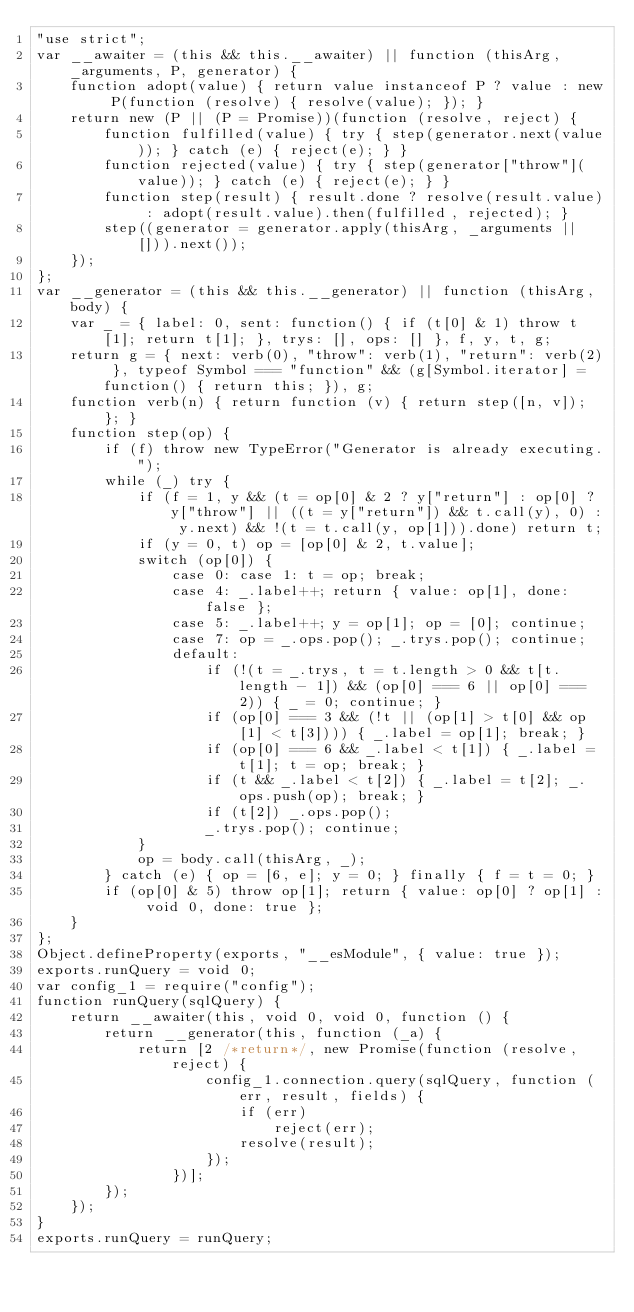<code> <loc_0><loc_0><loc_500><loc_500><_JavaScript_>"use strict";
var __awaiter = (this && this.__awaiter) || function (thisArg, _arguments, P, generator) {
    function adopt(value) { return value instanceof P ? value : new P(function (resolve) { resolve(value); }); }
    return new (P || (P = Promise))(function (resolve, reject) {
        function fulfilled(value) { try { step(generator.next(value)); } catch (e) { reject(e); } }
        function rejected(value) { try { step(generator["throw"](value)); } catch (e) { reject(e); } }
        function step(result) { result.done ? resolve(result.value) : adopt(result.value).then(fulfilled, rejected); }
        step((generator = generator.apply(thisArg, _arguments || [])).next());
    });
};
var __generator = (this && this.__generator) || function (thisArg, body) {
    var _ = { label: 0, sent: function() { if (t[0] & 1) throw t[1]; return t[1]; }, trys: [], ops: [] }, f, y, t, g;
    return g = { next: verb(0), "throw": verb(1), "return": verb(2) }, typeof Symbol === "function" && (g[Symbol.iterator] = function() { return this; }), g;
    function verb(n) { return function (v) { return step([n, v]); }; }
    function step(op) {
        if (f) throw new TypeError("Generator is already executing.");
        while (_) try {
            if (f = 1, y && (t = op[0] & 2 ? y["return"] : op[0] ? y["throw"] || ((t = y["return"]) && t.call(y), 0) : y.next) && !(t = t.call(y, op[1])).done) return t;
            if (y = 0, t) op = [op[0] & 2, t.value];
            switch (op[0]) {
                case 0: case 1: t = op; break;
                case 4: _.label++; return { value: op[1], done: false };
                case 5: _.label++; y = op[1]; op = [0]; continue;
                case 7: op = _.ops.pop(); _.trys.pop(); continue;
                default:
                    if (!(t = _.trys, t = t.length > 0 && t[t.length - 1]) && (op[0] === 6 || op[0] === 2)) { _ = 0; continue; }
                    if (op[0] === 3 && (!t || (op[1] > t[0] && op[1] < t[3]))) { _.label = op[1]; break; }
                    if (op[0] === 6 && _.label < t[1]) { _.label = t[1]; t = op; break; }
                    if (t && _.label < t[2]) { _.label = t[2]; _.ops.push(op); break; }
                    if (t[2]) _.ops.pop();
                    _.trys.pop(); continue;
            }
            op = body.call(thisArg, _);
        } catch (e) { op = [6, e]; y = 0; } finally { f = t = 0; }
        if (op[0] & 5) throw op[1]; return { value: op[0] ? op[1] : void 0, done: true };
    }
};
Object.defineProperty(exports, "__esModule", { value: true });
exports.runQuery = void 0;
var config_1 = require("config");
function runQuery(sqlQuery) {
    return __awaiter(this, void 0, void 0, function () {
        return __generator(this, function (_a) {
            return [2 /*return*/, new Promise(function (resolve, reject) {
                    config_1.connection.query(sqlQuery, function (err, result, fields) {
                        if (err)
                            reject(err);
                        resolve(result);
                    });
                })];
        });
    });
}
exports.runQuery = runQuery;
</code> 